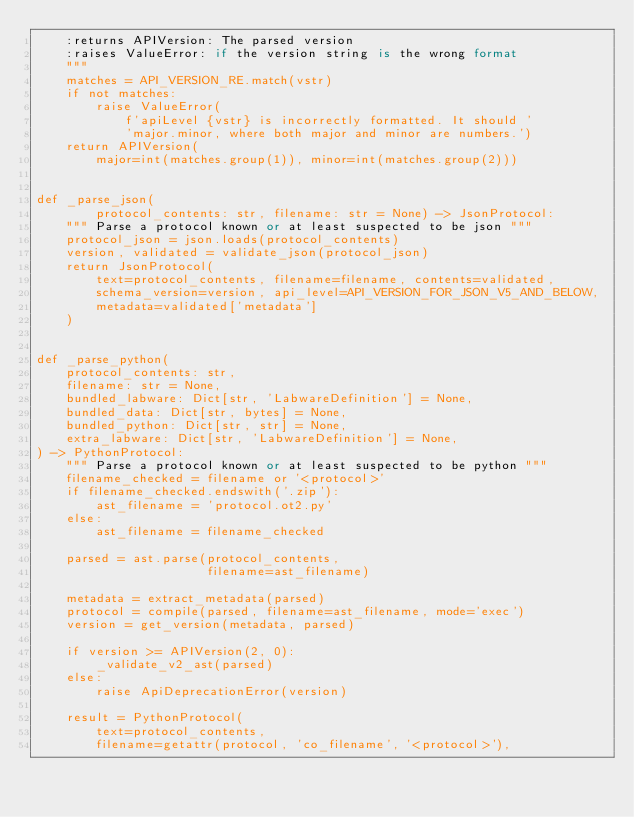Convert code to text. <code><loc_0><loc_0><loc_500><loc_500><_Python_>    :returns APIVersion: The parsed version
    :raises ValueError: if the version string is the wrong format
    """
    matches = API_VERSION_RE.match(vstr)
    if not matches:
        raise ValueError(
            f'apiLevel {vstr} is incorrectly formatted. It should '
            'major.minor, where both major and minor are numbers.')
    return APIVersion(
        major=int(matches.group(1)), minor=int(matches.group(2)))


def _parse_json(
        protocol_contents: str, filename: str = None) -> JsonProtocol:
    """ Parse a protocol known or at least suspected to be json """
    protocol_json = json.loads(protocol_contents)
    version, validated = validate_json(protocol_json)
    return JsonProtocol(
        text=protocol_contents, filename=filename, contents=validated,
        schema_version=version, api_level=API_VERSION_FOR_JSON_V5_AND_BELOW,
        metadata=validated['metadata']
    )


def _parse_python(
    protocol_contents: str,
    filename: str = None,
    bundled_labware: Dict[str, 'LabwareDefinition'] = None,
    bundled_data: Dict[str, bytes] = None,
    bundled_python: Dict[str, str] = None,
    extra_labware: Dict[str, 'LabwareDefinition'] = None,
) -> PythonProtocol:
    """ Parse a protocol known or at least suspected to be python """
    filename_checked = filename or '<protocol>'
    if filename_checked.endswith('.zip'):
        ast_filename = 'protocol.ot2.py'
    else:
        ast_filename = filename_checked

    parsed = ast.parse(protocol_contents,
                       filename=ast_filename)

    metadata = extract_metadata(parsed)
    protocol = compile(parsed, filename=ast_filename, mode='exec')
    version = get_version(metadata, parsed)

    if version >= APIVersion(2, 0):
        _validate_v2_ast(parsed)
    else:
        raise ApiDeprecationError(version)

    result = PythonProtocol(
        text=protocol_contents,
        filename=getattr(protocol, 'co_filename', '<protocol>'),</code> 